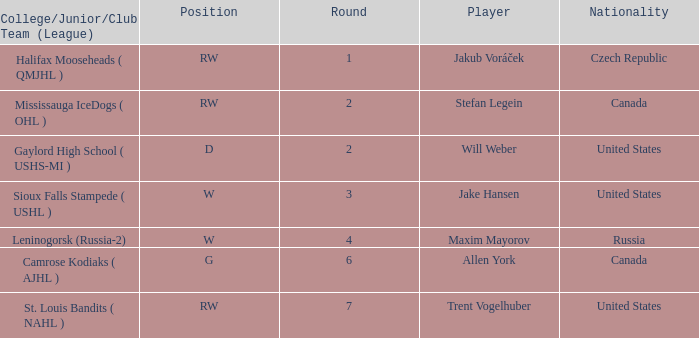From leninogorsk (russia-2), what is the nationality of the player in the w position who was drafted? Russia. 